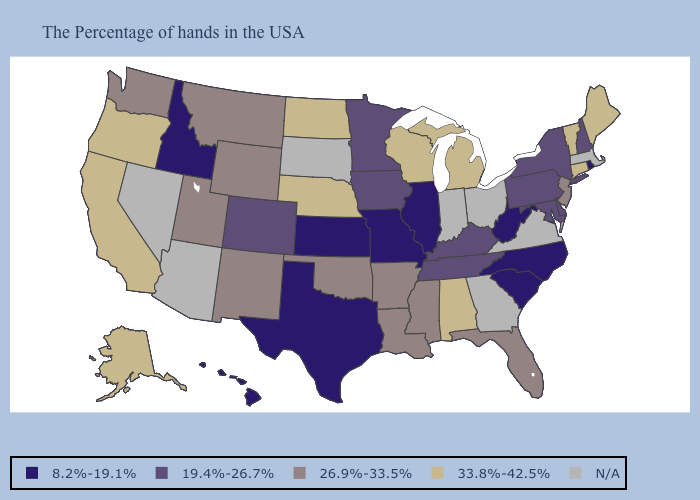Name the states that have a value in the range 33.8%-42.5%?
Concise answer only. Maine, Vermont, Connecticut, Michigan, Alabama, Wisconsin, Nebraska, North Dakota, California, Oregon, Alaska. Among the states that border Ohio , does Michigan have the highest value?
Concise answer only. Yes. What is the highest value in states that border Connecticut?
Be succinct. 19.4%-26.7%. Does Idaho have the lowest value in the West?
Concise answer only. Yes. Does the first symbol in the legend represent the smallest category?
Keep it brief. Yes. What is the value of Nebraska?
Concise answer only. 33.8%-42.5%. Which states have the highest value in the USA?
Give a very brief answer. Maine, Vermont, Connecticut, Michigan, Alabama, Wisconsin, Nebraska, North Dakota, California, Oregon, Alaska. Which states have the lowest value in the Northeast?
Answer briefly. Rhode Island. What is the value of Minnesota?
Keep it brief. 19.4%-26.7%. Does Idaho have the lowest value in the USA?
Keep it brief. Yes. What is the value of Wisconsin?
Concise answer only. 33.8%-42.5%. What is the value of Indiana?
Give a very brief answer. N/A. What is the value of Texas?
Quick response, please. 8.2%-19.1%. 